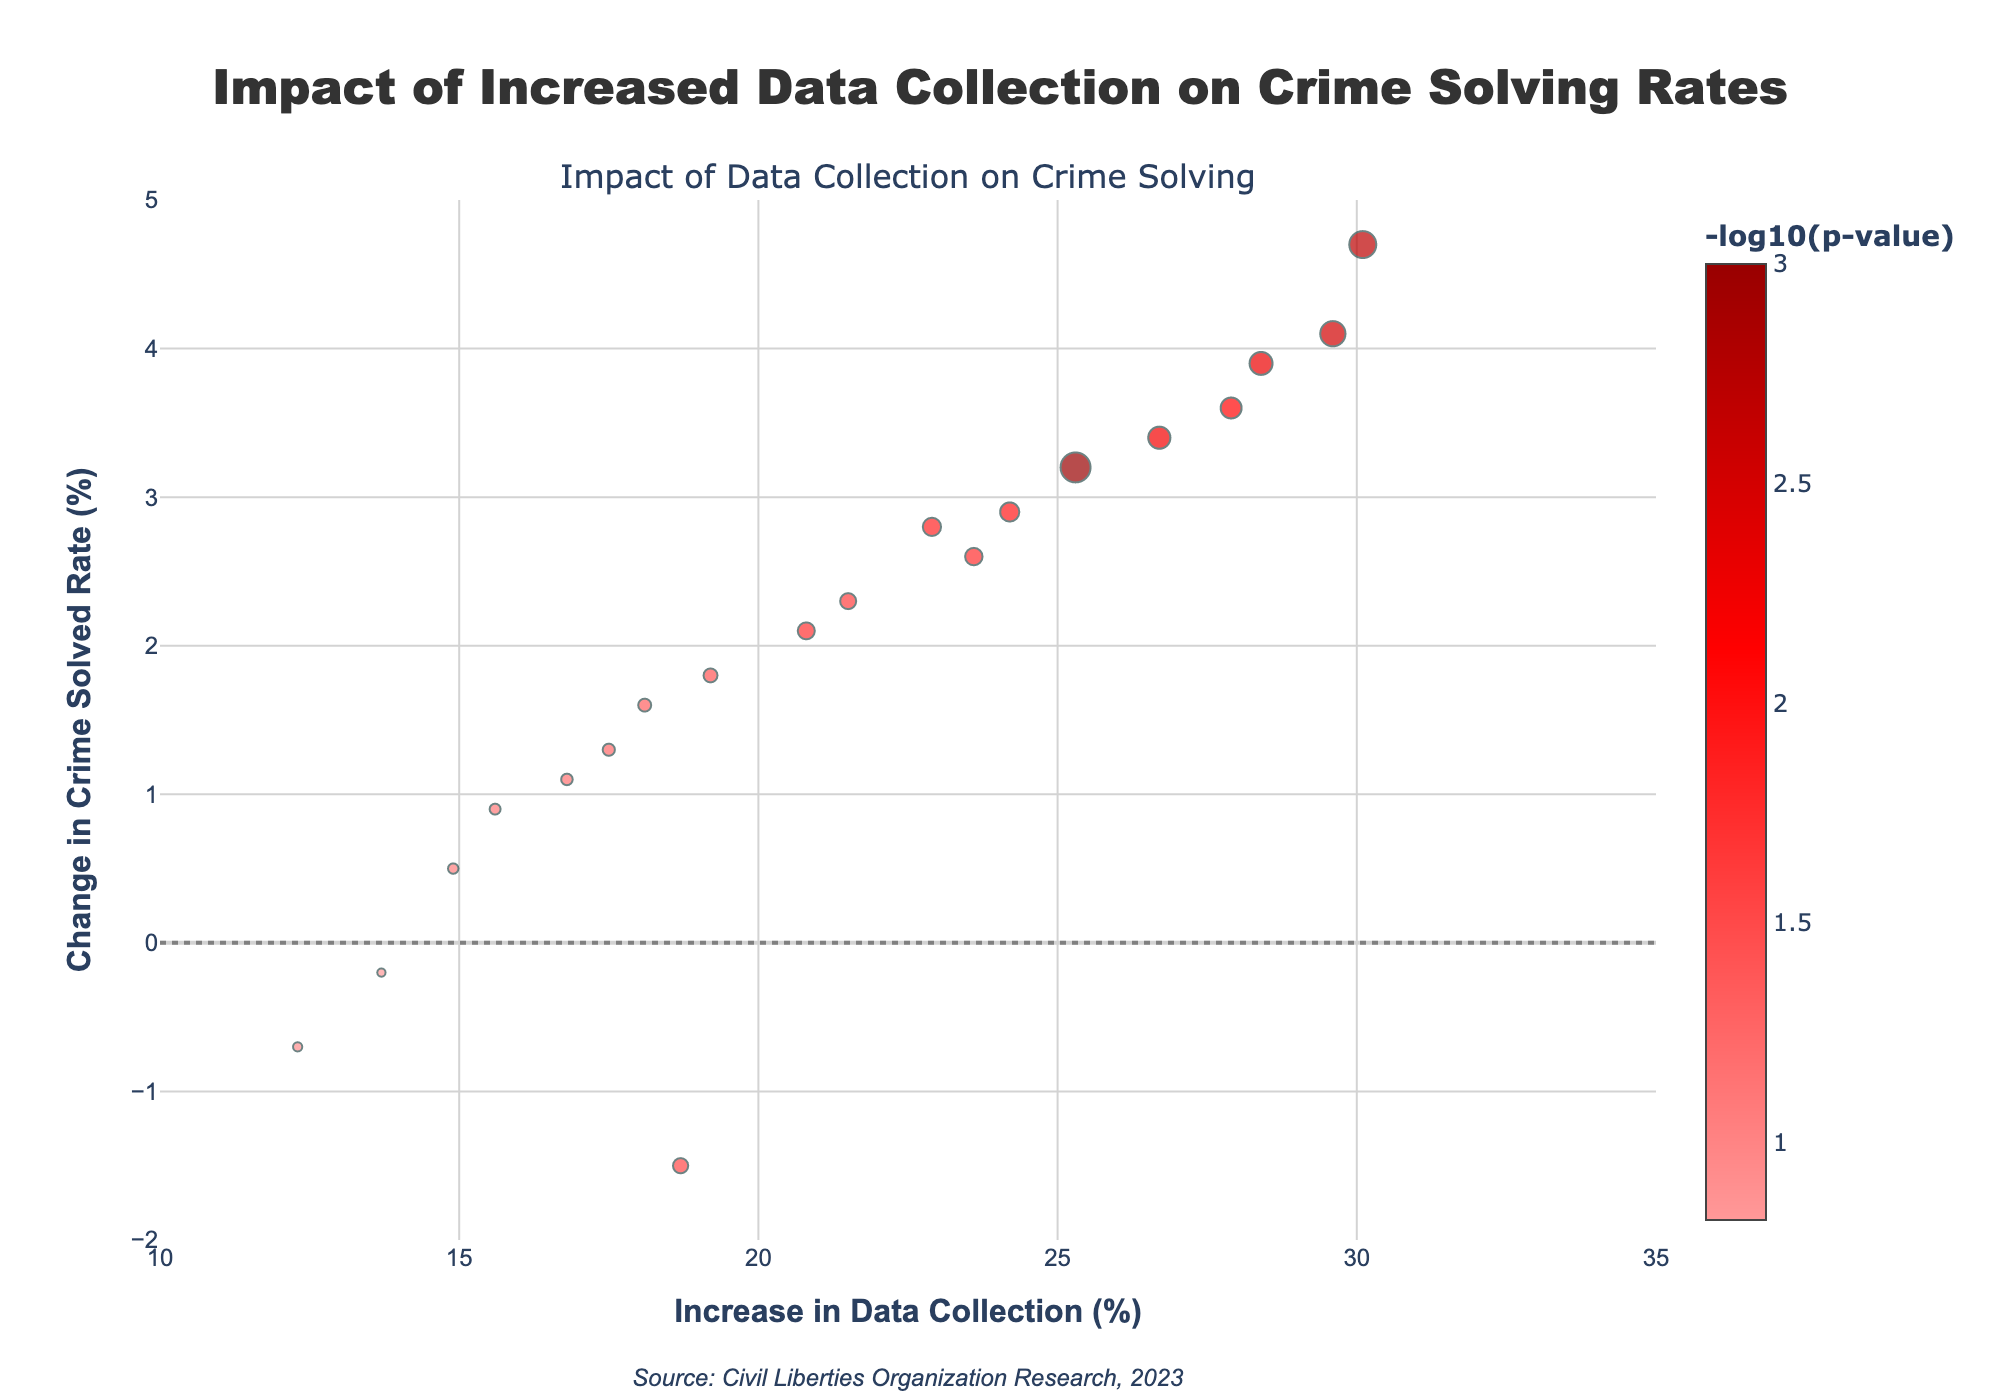What is the title of the plot? The title appears at the top center of the plot and reads "Impact of Increased Data Collection on Crime Solving Rates".
Answer: Impact of Increased Data Collection on Crime Solving Rates What does the x-axis represent? The x-axis title is "@Increase in Data Collection (%)", indicating it represents the percentage increase in data collection across different cities.
Answer: Increase in Data Collection (%) Which city has the highest increase in data collection? By checking the x-axis for the highest value, New York has the highest increase in data collection at 25.3%.
Answer: New York How many data points are in the plot? There are markers on the plot representing different cities. Counting them gives us a total of 20 data points.
Answer: 20 What is the range of change in the crime solved rate? The y-axis represents the "Change in Crime Solved Rate (%)". The range of this axis goes from -2% to 5%.
Answer: -2% to 5% Explain the color scale used in the plot. The color scale represents the -log10(p-value) of each data point. It uses a gradient from light red to dark red with six different shades representing different significance levels.
Answer: A gradient from light red to dark red Which city had the highest positive change in the crime solved rate, and what was its p-value? Chicago had the highest positive crime solved rate change at 4.7%. By checking the marker's color, its p-value corresponds to a high -log10(p-value) value, indicating strong significance, and the p-value is 0.002.
Answer: Chicago, 0.002 Which city has a decrease in crime solved rate despite an increase in data collection? By looking for markers below the 0% y-axis line, Los Angeles shows a crime solved rate decrease at -1.5% with a corresponding increase in data collection of 18.7%.
Answer: Los Angeles What is the significance (p-value) of the change in crime solved rate for Philadelphia and how does its color compare to other cities? For Philadelphia, the p-value is 0.005. Its color appears somewhere in the middle of the color scale, indicating moderate significance compared to stronger or weaker colors.
Answer: 0.005, moderate significance What is the overall trend observed in the plot about data collection and its impact on crime solving? Generally, most data points with higher data collection increase tend to have positive crime solved rate change, suggesting a weak positive trend. However, there are a few exceptions where increases in data collection correlate with negative changes in crime solving rates.
Answer: Weak positive trend with exceptions 